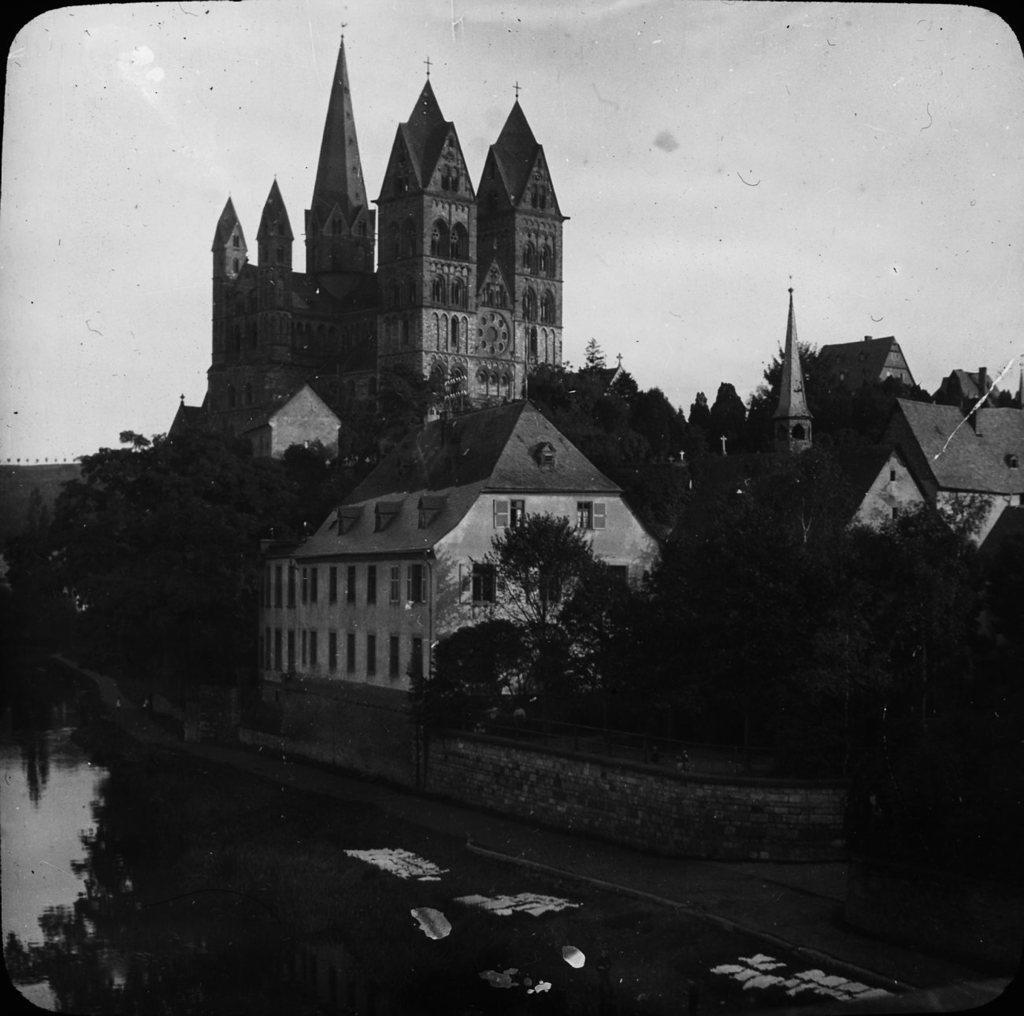Please provide a concise description of this image. This is a black and white picture. At the bottom, we see water and this water might be in the pond. There are trees and buildings in the background. At the top, we see the sky. This picture might be a photo frame. 